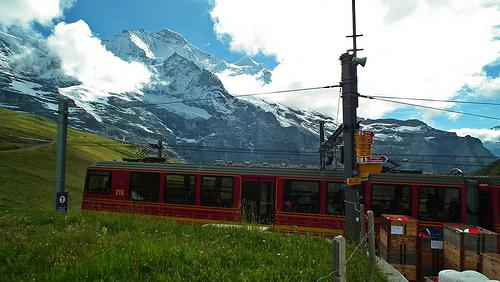Question: what color are the clouds?
Choices:
A. White.
B. Grey.
C. Black.
D. Brown.
Answer with the letter. Answer: A Question: what color is the grass?
Choices:
A. Yellow.
B. Brown.
C. Green.
D. White.
Answer with the letter. Answer: C 